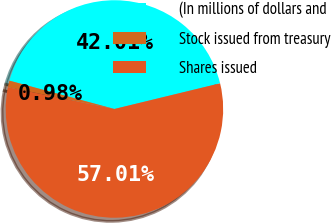Convert chart to OTSL. <chart><loc_0><loc_0><loc_500><loc_500><pie_chart><fcel>(In millions of dollars and<fcel>Stock issued from treasury<fcel>Shares issued<nl><fcel>42.01%<fcel>0.98%<fcel>57.0%<nl></chart> 